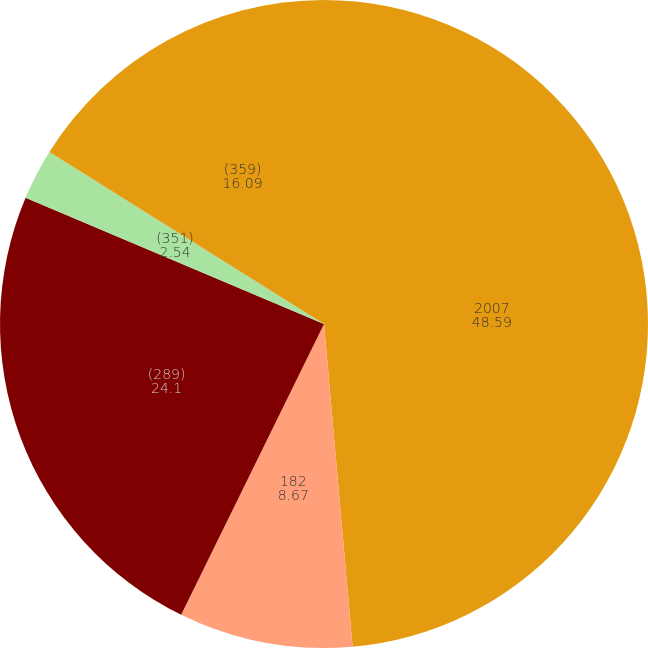Convert chart. <chart><loc_0><loc_0><loc_500><loc_500><pie_chart><fcel>2007<fcel>182<fcel>(289)<fcel>(351)<fcel>(359)<nl><fcel>48.59%<fcel>8.67%<fcel>24.1%<fcel>2.54%<fcel>16.09%<nl></chart> 